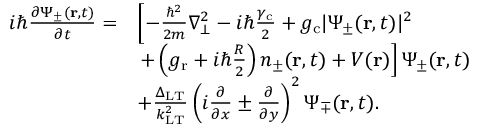<formula> <loc_0><loc_0><loc_500><loc_500>\begin{array} { r l } { i \hbar { } \partial \Psi _ { \pm } ( r , t ) } { \partial t } = } & { \left [ - \frac { \hbar { ^ } { 2 } } { 2 m } \nabla _ { \bot } ^ { 2 } - i \hbar { } \gamma _ { c } } { 2 } + g _ { c } | \Psi _ { \pm } ( r , t ) | ^ { 2 } } \\ & { + \left ( g _ { r } + i \hbar { } R } { 2 } \right ) n _ { \pm } ( r , t ) + V ( r ) \right ] \Psi _ { \pm } ( r , t ) } \\ & { + \frac { \Delta _ { L T } } { k _ { L T } ^ { 2 } } \left ( i \frac { \partial } { \partial x } \pm \frac { \partial } { \partial y } \right ) ^ { 2 } \Psi _ { \mp } ( r , t ) . } \end{array}</formula> 